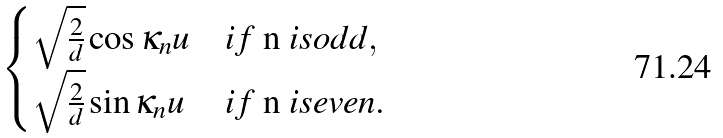Convert formula to latex. <formula><loc_0><loc_0><loc_500><loc_500>\begin{cases} \sqrt { \frac { 2 } { d } } \cos \kappa _ { n } u & i f $ n $ i s o d d , \\ \sqrt { \frac { 2 } { d } } \sin \kappa _ { n } u & i f $ n $ i s e v e n . \end{cases}</formula> 